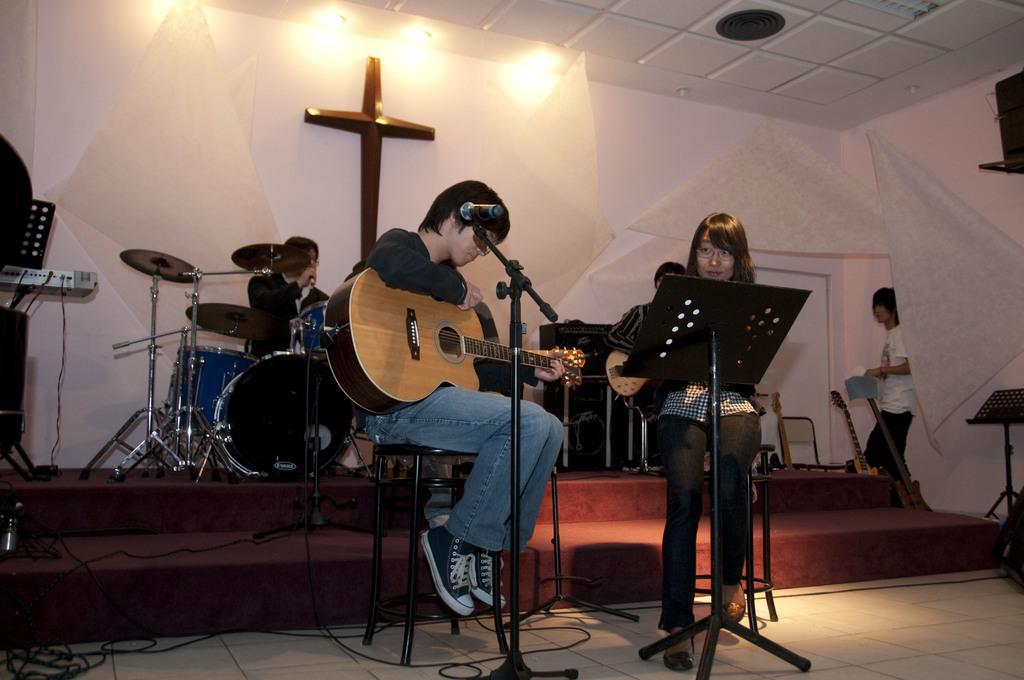Can you describe this image briefly? In this picture that a group of people sitting, among them one person is playing the guitar, the woman beside him was staring at him. The person who is sitting near drum set is using a microphone and their some lights attached in ceiling. 